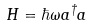<formula> <loc_0><loc_0><loc_500><loc_500>H = \hbar { \omega } a ^ { \dagger } a</formula> 